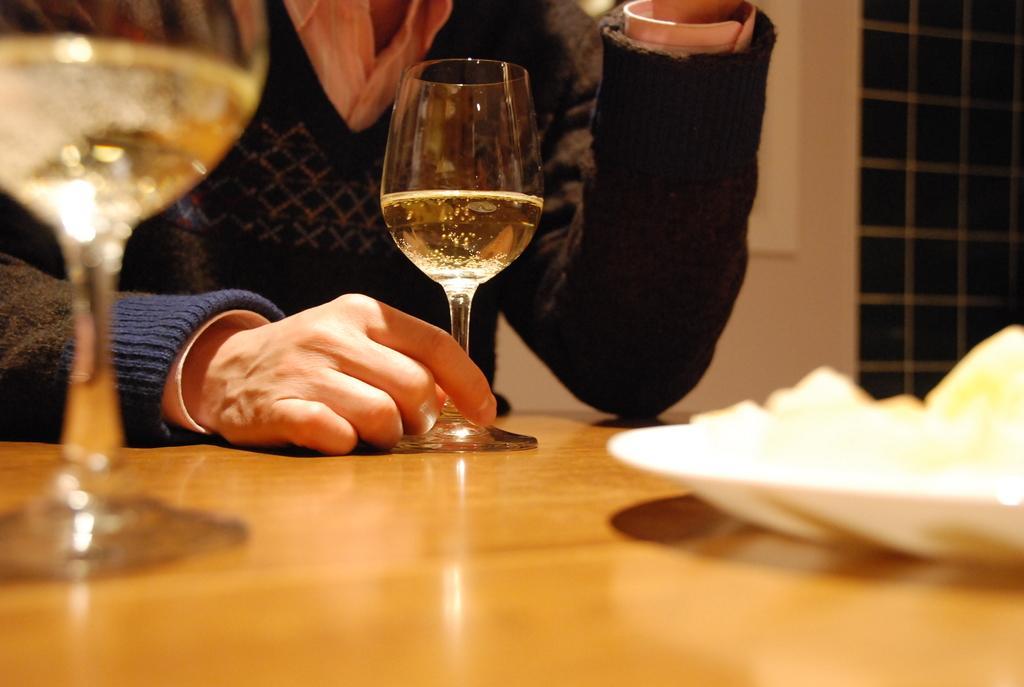How would you summarize this image in a sentence or two? In the middle of the image there is a table, On the table there is a glass. Top left side of the image there is a glass. Bottom right of the image there is a plate on the table. Top right side of the image there is a wall. 